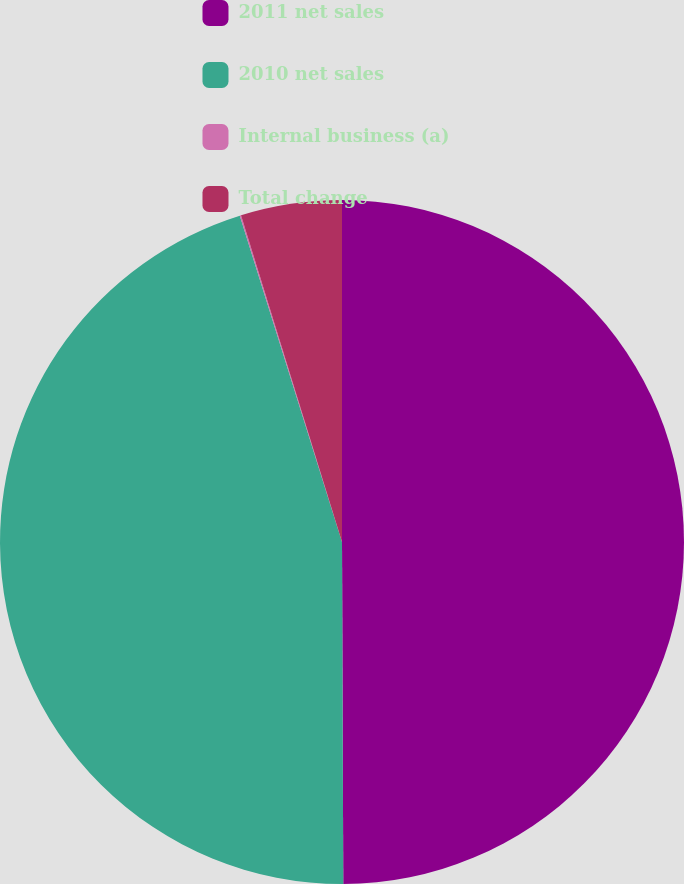Convert chart. <chart><loc_0><loc_0><loc_500><loc_500><pie_chart><fcel>2011 net sales<fcel>2010 net sales<fcel>Internal business (a)<fcel>Total change<nl><fcel>49.94%<fcel>45.23%<fcel>0.06%<fcel>4.77%<nl></chart> 